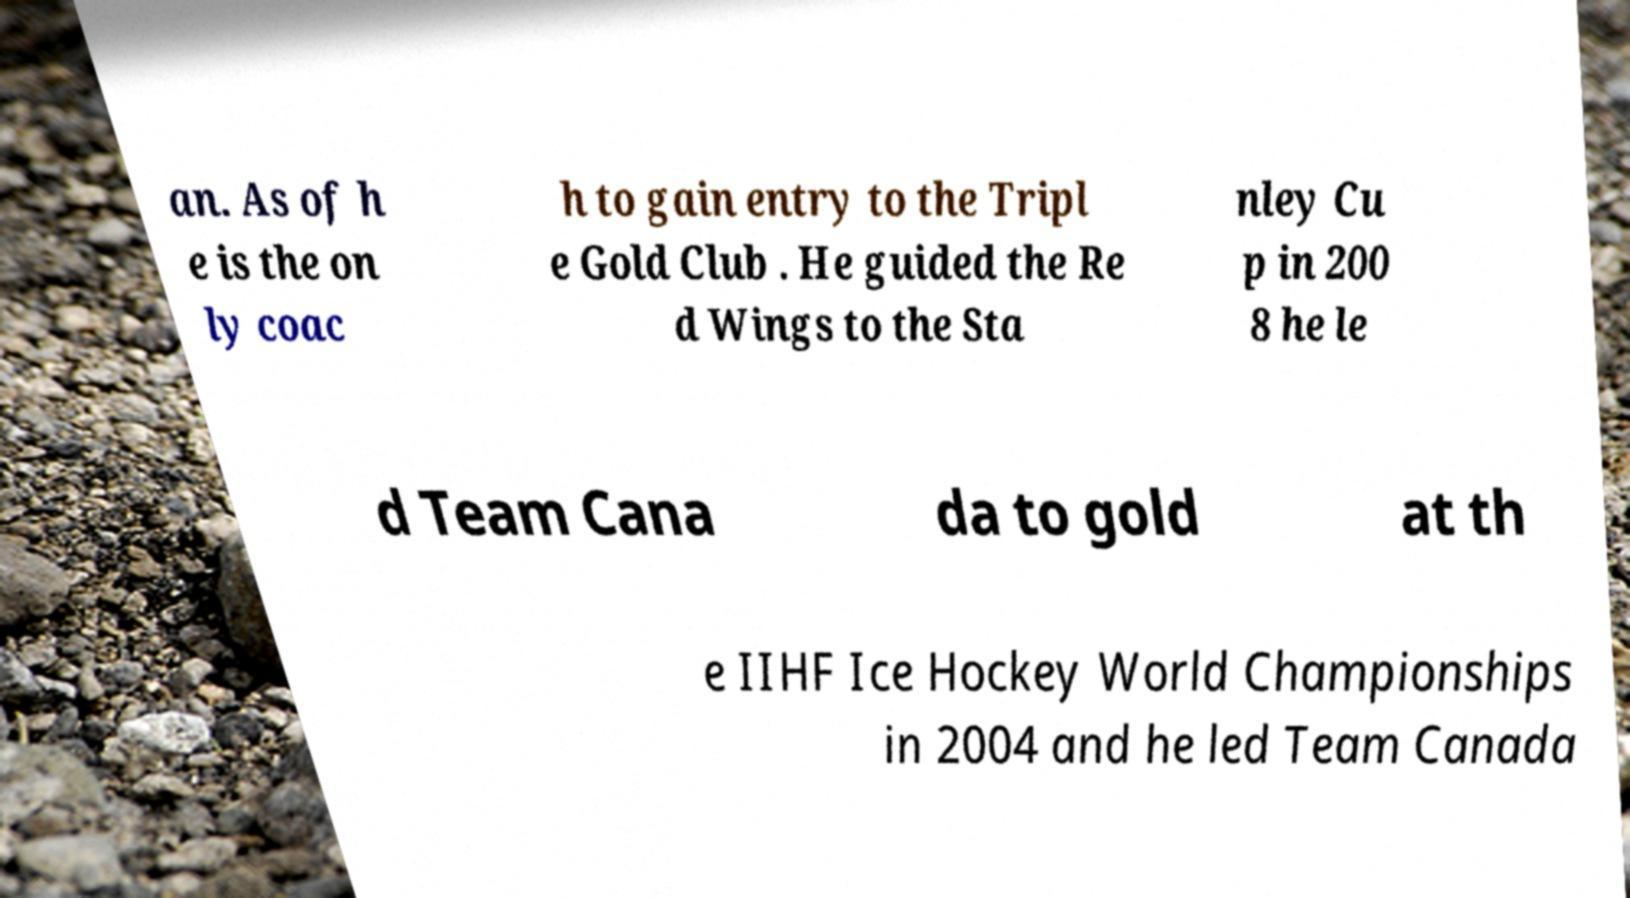Could you assist in decoding the text presented in this image and type it out clearly? an. As of h e is the on ly coac h to gain entry to the Tripl e Gold Club . He guided the Re d Wings to the Sta nley Cu p in 200 8 he le d Team Cana da to gold at th e IIHF Ice Hockey World Championships in 2004 and he led Team Canada 